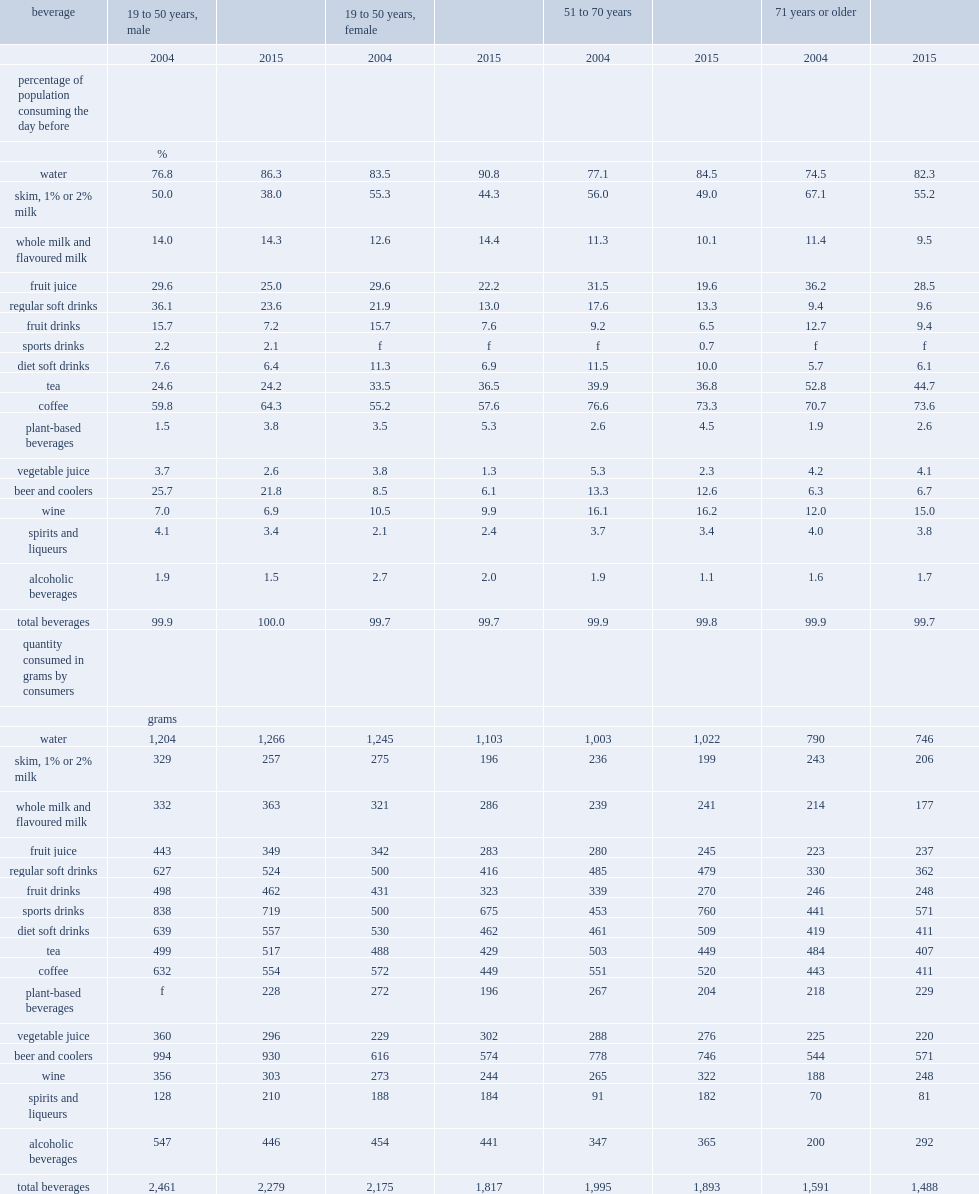Among adults, what is the most commonly consumed beverage the day before the interview? Water. What is the least difference between the percentage of water consumers in 2004 and in 2015, acroos all adult age and sex categories? 7.3. For skim, 1% or 2%milk consumers, which year has a lower percentage of consumers, 2004 or 2015? 2015.0. For skim, 1% or 2% milk, which year has a lower average quantity consumed, 2004 or 2015? 2015.0. 